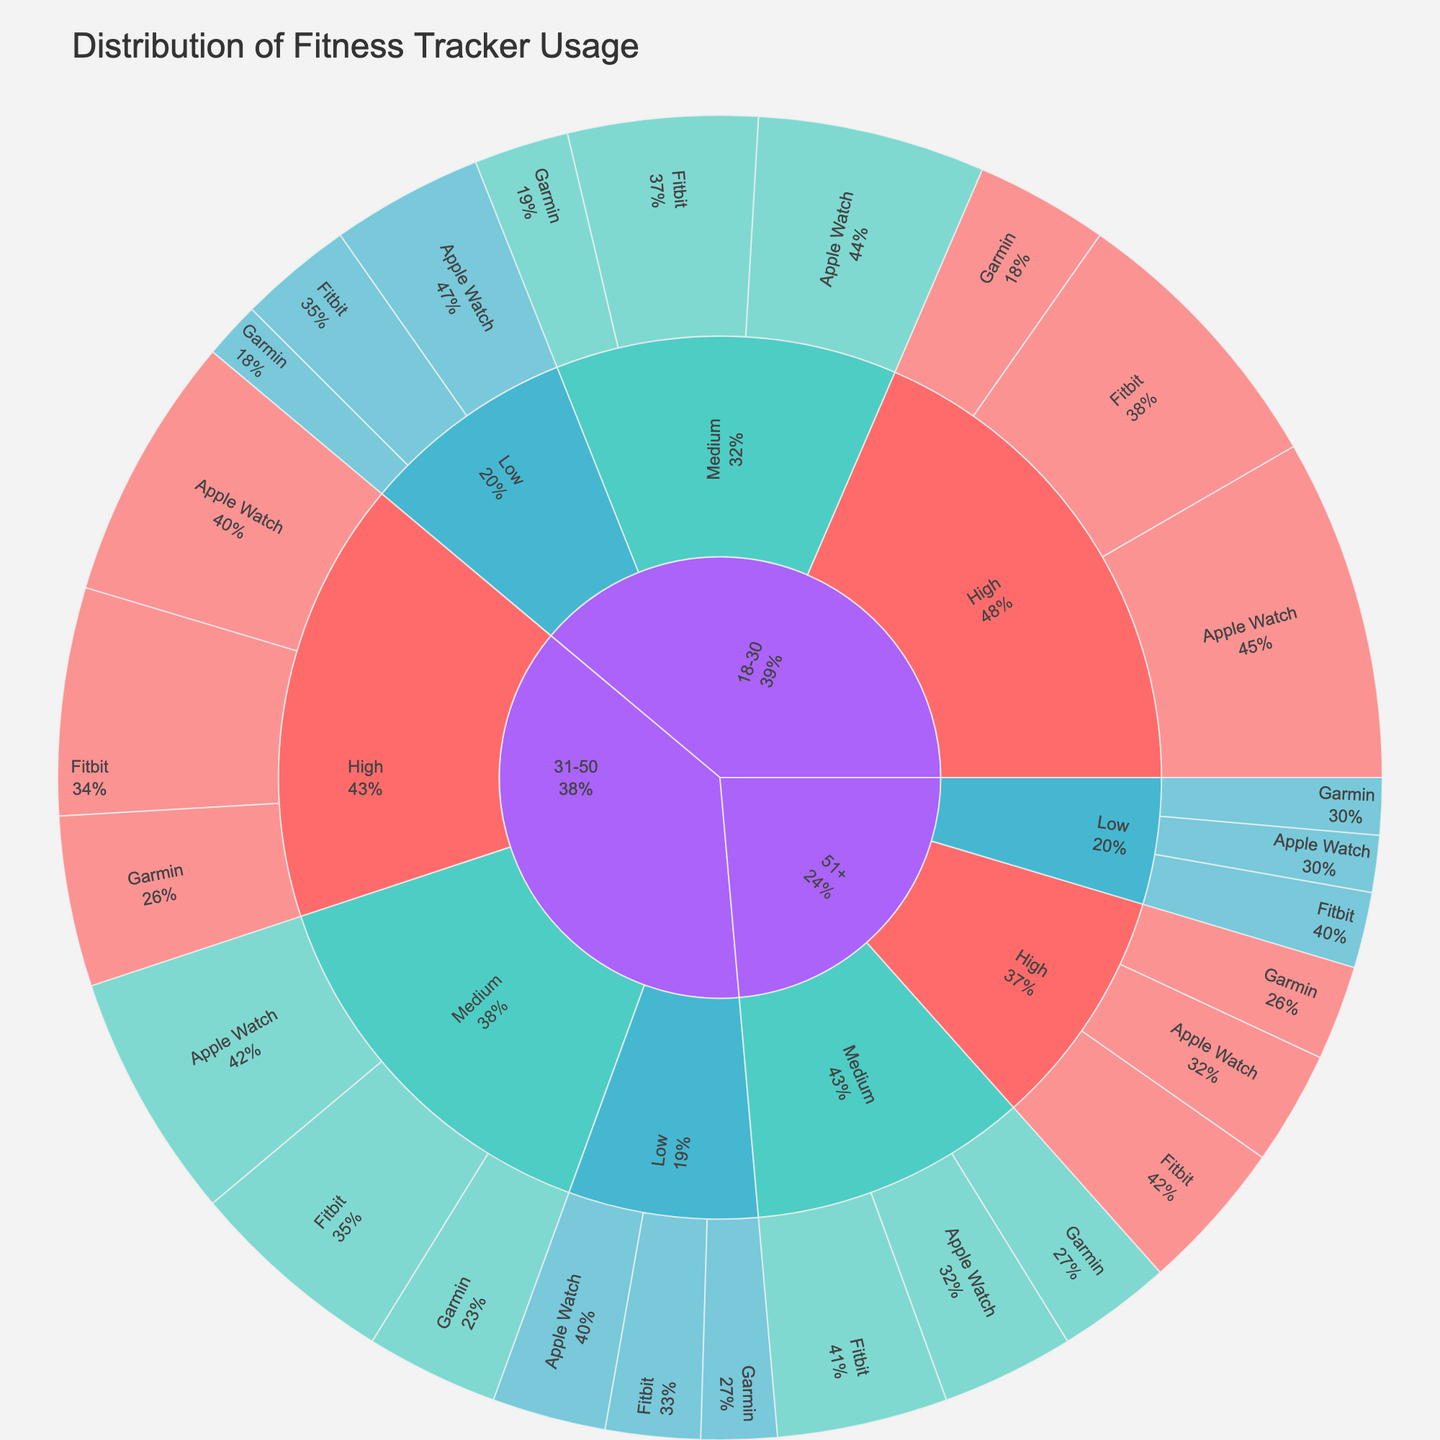what's the title of the figure? The title of the figure is often placed prominently at the top and describes the main content or purpose of the plot. In this case, the title is "Distribution of Fitness Tracker Usage".
Answer: Distribution of Fitness Tracker Usage what color represents high activity level? Colors are used to distinguish between different activity levels in the Sunburst Plot. The color that represents a high activity level is visually identifiable by its distinct hue, which is bright red (#FF6B6B).
Answer: red how many age groups are represented in the figure? The main slices of the Sunburst Plot start with the primary categories, which are the age groups. Each distinct segment represents a different age group. There are three primary slices or segments in the Sunburst Plot, indicating there are three age groups represented.
Answer: 3 what percentage of fitness tracker usage is attributed to Apple Watch among the 18-30 age group with high activity level? To determine the percentage, navigate through the plot's hierarchy to the segment for the 18-30 age group with a high activity level and further into the Apple Watch brand segment. The corresponding percentage is labeled on this segment. The percentage value is 18%.
Answer: 18% which age group has the largest representation in the medium activity level? By comparing the sizes of the segments under the medium activity level across different age groups, count or visually assess the segments' proportions to determine the largest. For the medium activity level, the largest segment is for the 31-50 age group.
Answer: 31-50 which activity level has the smallest overall representation in the 51+ age group? By examining the different activity level segments within the 51+ age group and comparing their sizes, the smallest overall representation can be identified. The smallest segment is the low activity level.
Answer: low what is the combined percentage of Garmin use in the medium activity level across all age groups? Sum the percentages for Garmin under the medium activity level for each age group: 18-30 (5%), 31-50 (7%), and 51+ (6%). The combined percentage is 5 + 7 + 6 = 18%.
Answer: 18% compare the percentage of Fitbit usage between high and low activity levels in the 18-30 age group Locate the segments for Fitbit usage in the 18-30 age group under both high and low activity levels and compare the percentages. For high activity, the percentage is 15%, and for low activity, it is 6%.
Answer: High usage: 15%, Low usage: 6% which fitness tracker brand has the highest percentage of usage in the medium activity level of the 51+ age group? Navigate within the sunburst plot to the 51+ age group, then to the medium activity level, and finally identify the segment with the highest percentage among the fitness tracker brands. The highest percentage is attributed to Fitbit, which is 9%.
Answer: Fitbit, 9% is the percentage of Apple Watch users in the high activity level of the 31-50 age group greater than the percentage of Garmin users in the same group and activity level? Compare the percentage values of Apple Watch and Garmin within the high activity level segment of the 31-50 age group. Apple Watch has 14%, and Garmin has 9%, so Apple Watch usage is greater.
Answer: Yes 